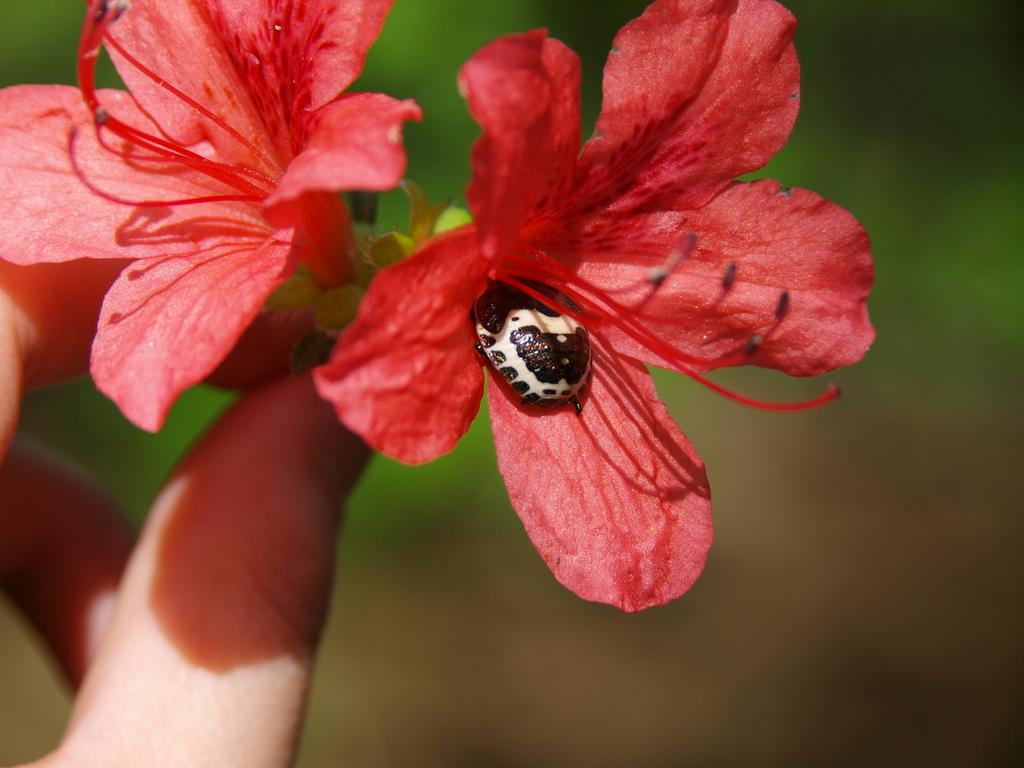What is the insect on in the image? The insect is on a flower in the image. What is the person's hand holding in the image? The person's hand is holding two shoe flowers in the image. What color are the shoe flowers? The shoe flowers are red in color. How would you describe the background of the image? The background appears blurry in the image. How does the person in the image push the insect away from the flower? There is no indication in the image that the person is pushing the insect away from the flower. 